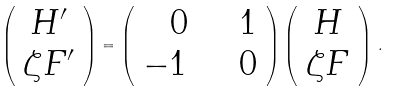<formula> <loc_0><loc_0><loc_500><loc_500>\left ( \begin{array} { c } H ^ { \prime } \\ \zeta F ^ { \prime } \end{array} \right ) = \left ( \begin{array} { r r } 0 \quad & 1 \\ - 1 \quad & 0 \end{array} \right ) \left ( \begin{array} { c } H \\ \zeta F \end{array} \right ) \, .</formula> 